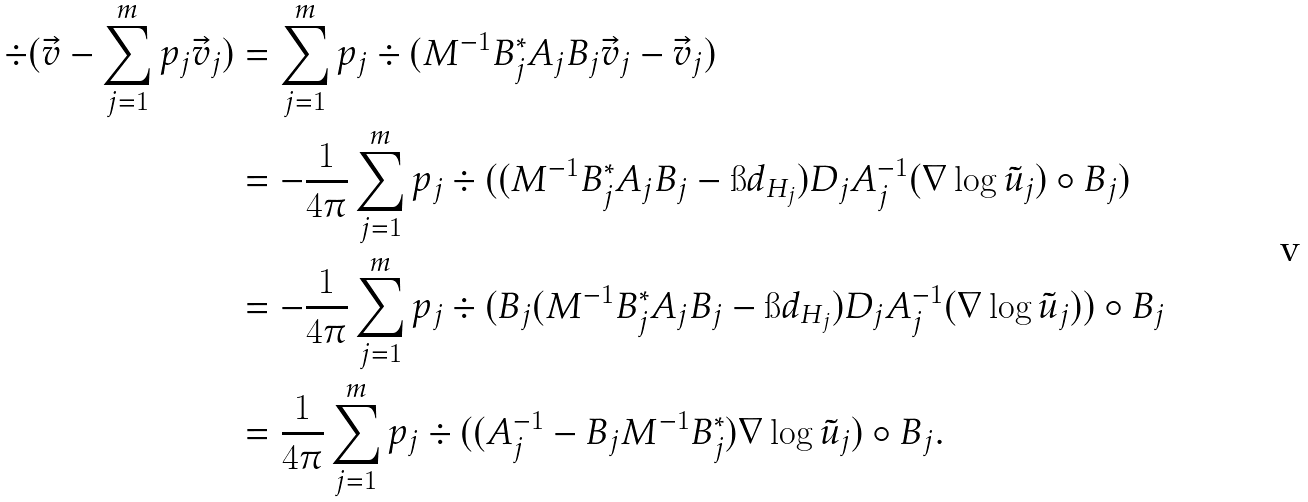<formula> <loc_0><loc_0><loc_500><loc_500>\div ( \vec { v } - \sum _ { j = 1 } ^ { m } p _ { j } \vec { v } _ { j } ) & = \sum _ { j = 1 } ^ { m } p _ { j } \div ( M ^ { - 1 } B _ { j } ^ { * } A _ { j } B _ { j } \vec { v } _ { j } - \vec { v } _ { j } ) \\ & = - \frac { 1 } { 4 \pi } \sum _ { j = 1 } ^ { m } p _ { j } \div ( ( M ^ { - 1 } B _ { j } ^ { * } A _ { j } B _ { j } - \i d _ { H _ { j } } ) D _ { j } A _ { j } ^ { - 1 } ( \nabla \log \tilde { u } _ { j } ) \circ B _ { j } ) \\ & = - \frac { 1 } { 4 \pi } \sum _ { j = 1 } ^ { m } p _ { j } \div ( B _ { j } ( M ^ { - 1 } B _ { j } ^ { * } A _ { j } B _ { j } - \i d _ { H _ { j } } ) D _ { j } A _ { j } ^ { - 1 } ( \nabla \log \tilde { u } _ { j } ) ) \circ B _ { j } \\ & = \frac { 1 } { 4 \pi } \sum _ { j = 1 } ^ { m } p _ { j } \div ( ( A _ { j } ^ { - 1 } - B _ { j } M ^ { - 1 } B _ { j } ^ { * } ) \nabla \log \tilde { u } _ { j } ) \circ B _ { j } .</formula> 